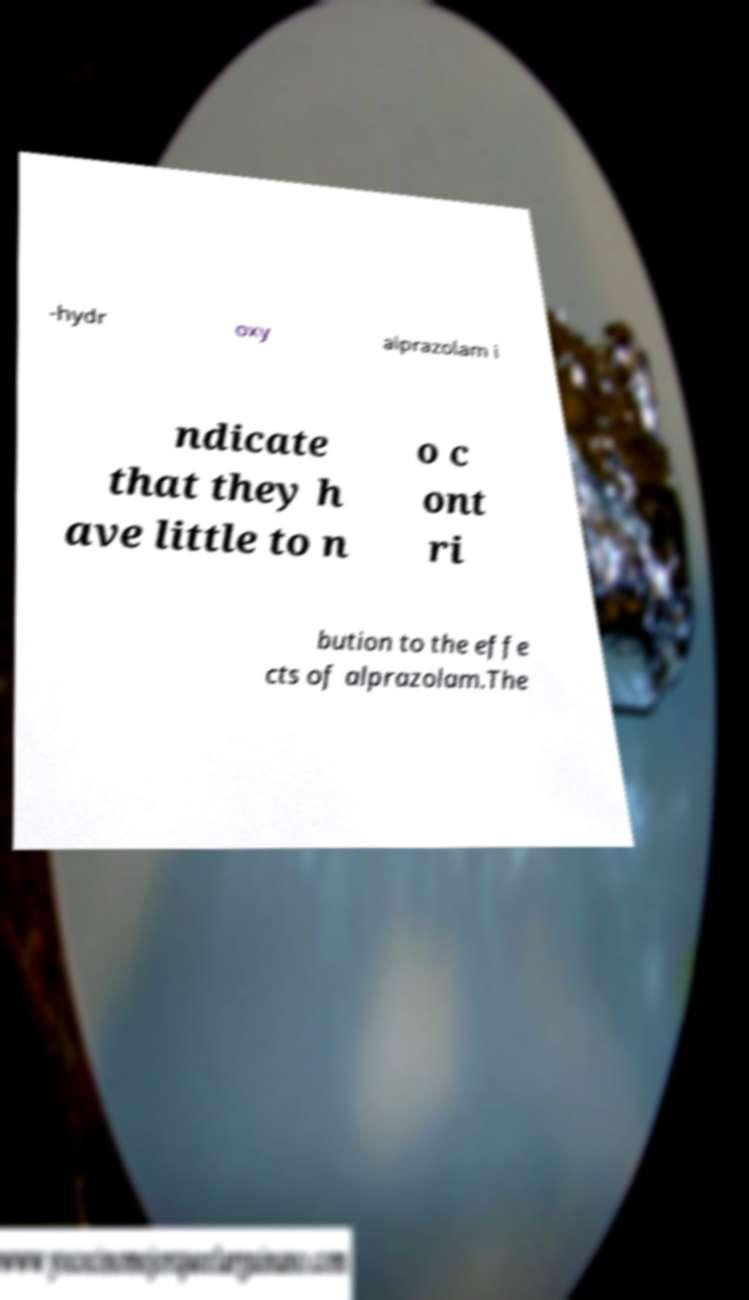Can you accurately transcribe the text from the provided image for me? -hydr oxy alprazolam i ndicate that they h ave little to n o c ont ri bution to the effe cts of alprazolam.The 